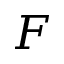<formula> <loc_0><loc_0><loc_500><loc_500>F</formula> 